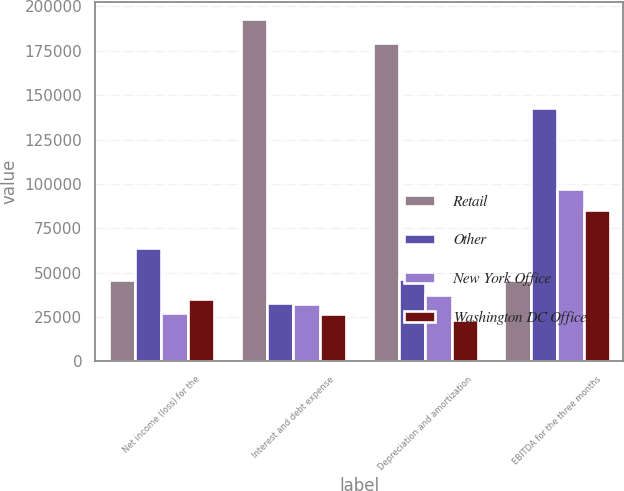Convert chart. <chart><loc_0><loc_0><loc_500><loc_500><stacked_bar_chart><ecel><fcel>Net income (loss) for the<fcel>Interest and debt expense<fcel>Depreciation and amortization<fcel>EBITDA for the three months<nl><fcel>Retail<fcel>45701<fcel>192839<fcel>179574<fcel>45701<nl><fcel>Other<fcel>63813<fcel>32979<fcel>46113<fcel>142905<nl><fcel>New York Office<fcel>27173<fcel>32244<fcel>37222<fcel>97340<nl><fcel>Washington DC Office<fcel>34907<fcel>26733<fcel>23488<fcel>85133<nl></chart> 